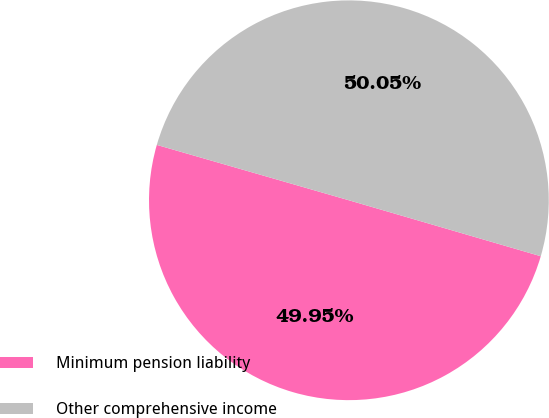Convert chart to OTSL. <chart><loc_0><loc_0><loc_500><loc_500><pie_chart><fcel>Minimum pension liability<fcel>Other comprehensive income<nl><fcel>49.95%<fcel>50.05%<nl></chart> 